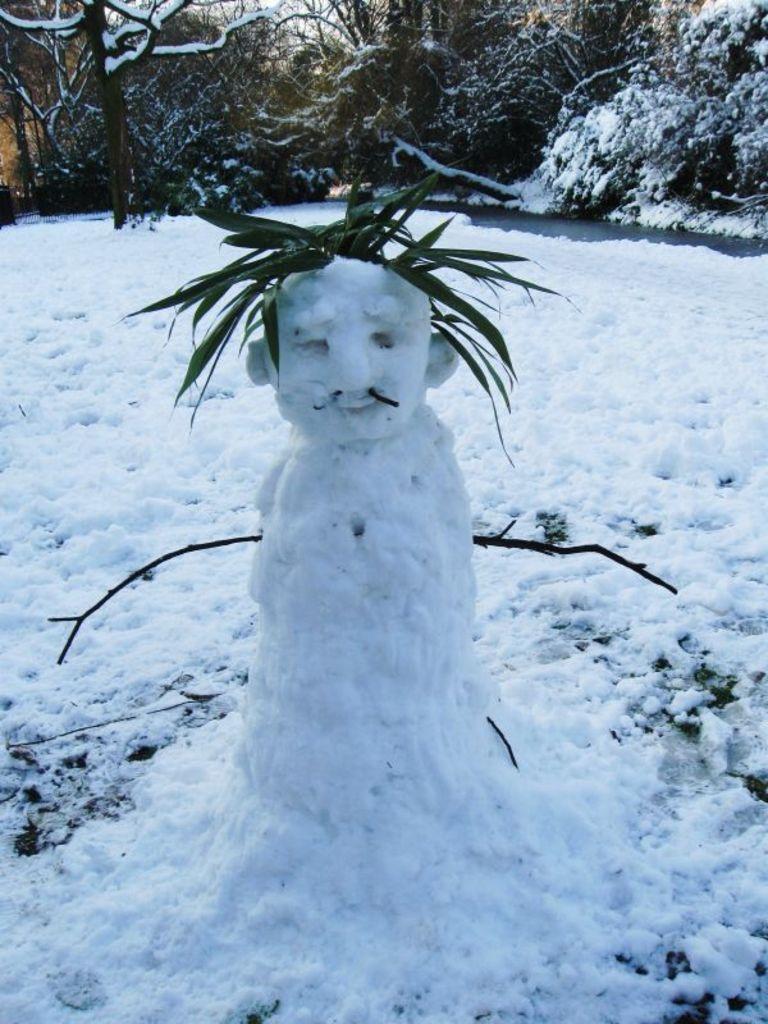Could you give a brief overview of what you see in this image? In this image, we can see an object made with snow and some leaves. We can see some trees and the snow. 